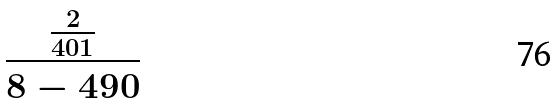Convert formula to latex. <formula><loc_0><loc_0><loc_500><loc_500>\frac { \frac { 2 } { 4 0 1 } } { 8 - 4 9 0 }</formula> 